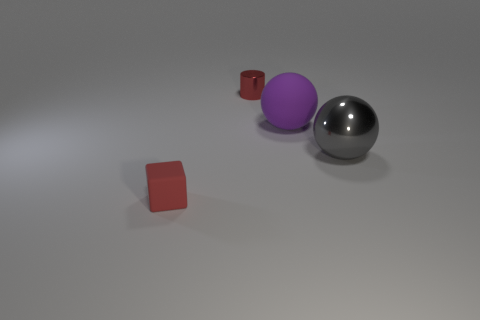What ambiance does the image's color scheme create? The image's color scheme, featuring muted grays, a bold purple, and red accents, creates a modern and minimalistic ambiance. The contrast between the matte and shiny textures further adds to the contemporary feel of the scene. 